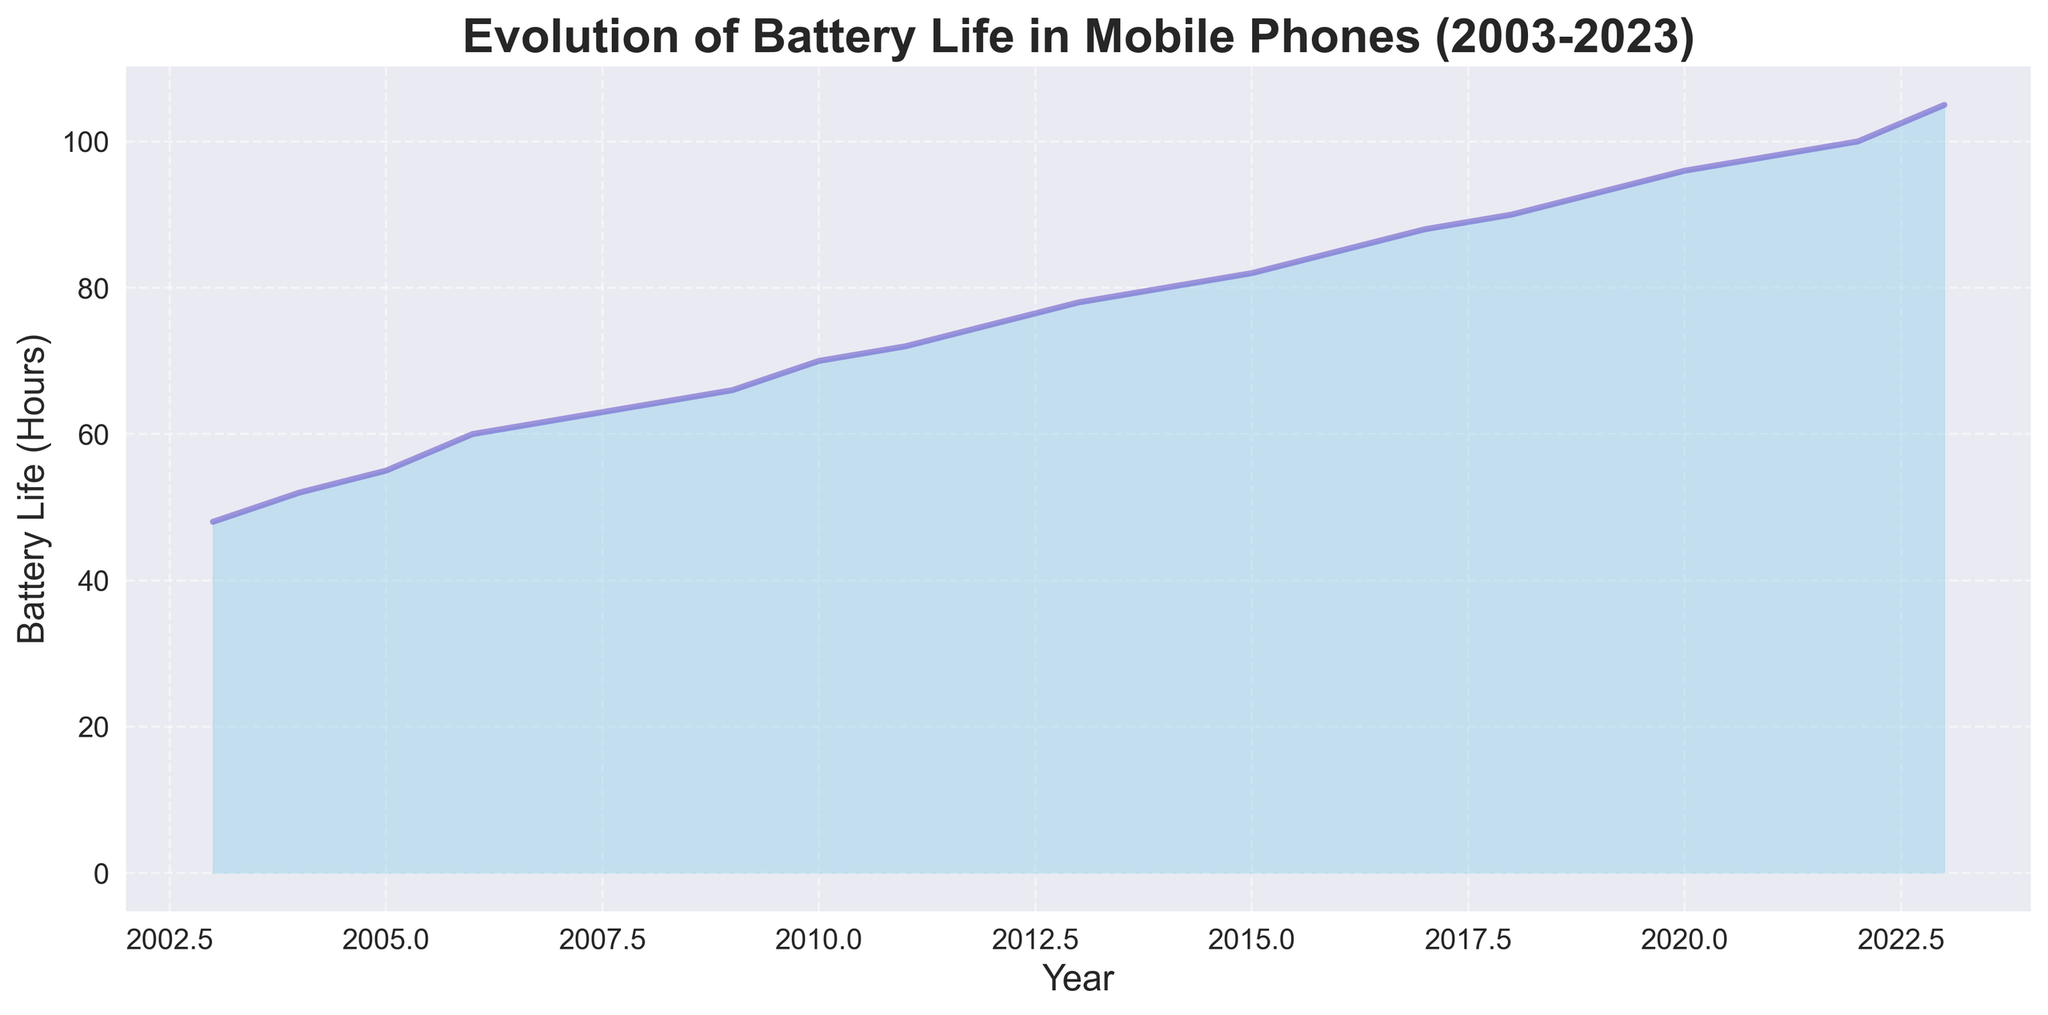Which year saw the smallest increase in battery life from the previous year? We observe the difference in battery life year by year. The smallest increase is from 2006 to 2007, where the difference is 2 hours (62-60).
Answer: 2007 What's the average battery life in the first 5 years shown on the chart? Sum the battery life hours for the first 5 years (2003-2007): 48, 52, 55, 60, 62, which equals 277. Divide by 5 to find the average: 277/5 = 55.4
Answer: 55.4 hours In which year did battery life first exceed 90 hours? By observing the chart, battery life first exceeds 90 hours in the year 2019, where it is recorded as 93 hours.
Answer: 2019 Which period had the faster increase in battery life: 2003-2008 or 2018-2023? Calculate the increase for both periods. For 2003-2008, it increased from 48 hours to 64 hours (64-48 = 16 hours). For 2018-2023, it increased from 90 hours to 105 hours (105-90 = 15 hours). Thus, the faster increase was from 2003-2008.
Answer: 2003-2008 How many years did it take for the battery life to double from its initial value? The initial value in 2003 was 48 hours. Double this value is 96 hours. Observing the chart, this occurs in the year 2020. Therefore, it took from 2003 to 2020, which is 17 years.
Answer: 17 years Which year displayed the most noticeable positive trend in battery life? The year with the steepest increase is between 2022 and 2023. The increase is noticeable as it jumps from 100 to 105 hours, suggesting a significant trend.
Answer: 2023 What's the total increase in battery life from 2010 to 2023? Calculate the difference between the battery life in 2010 and 2023. Battery life in 2010: 70 hours; Battery life in 2023: 105 hours. Therefore, the increase is 105-70 = 35 hours.
Answer: 35 hours What's the median value of the battery life data? There are 21 data points, so the median is the value at the 11th position when sorted in ascending order. The median battery life value is at the year 2013, which is 78 hours.
Answer: 78 hours Between which consecutive years was the change in battery life smallest? By checking the yearly differences, the smallest change is between 2006 and 2007, where the increase was only 2 hours (60 to 62).
Answer: 2006-2007 Which year marks the first point where the battery life crossed 70 hours? Referring to the chart, the first year the battery life crossed 70 hours was 2010, where it reached exactly 70 hours.
Answer: 2010 